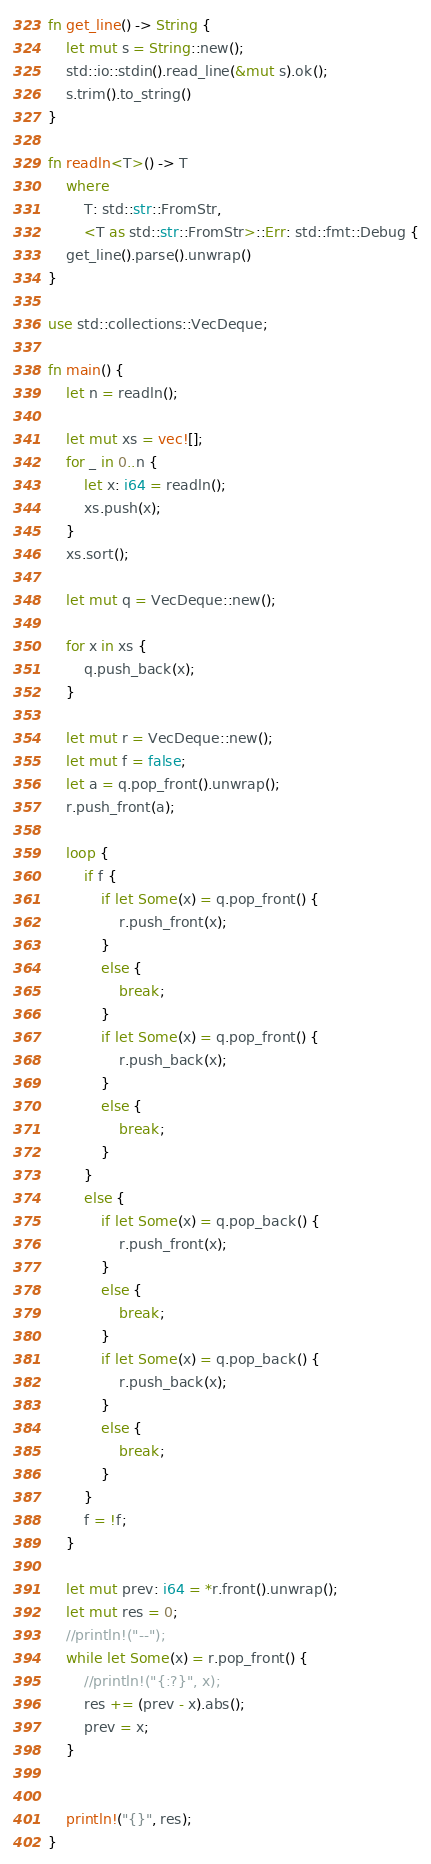<code> <loc_0><loc_0><loc_500><loc_500><_Rust_>fn get_line() -> String {
    let mut s = String::new();
    std::io::stdin().read_line(&mut s).ok();
    s.trim().to_string()
}

fn readln<T>() -> T
    where
        T: std::str::FromStr,
        <T as std::str::FromStr>::Err: std::fmt::Debug {
    get_line().parse().unwrap()
}

use std::collections::VecDeque;

fn main() {
    let n = readln();

    let mut xs = vec![];
    for _ in 0..n {
        let x: i64 = readln();
        xs.push(x);
    }
    xs.sort();

    let mut q = VecDeque::new();

    for x in xs {
        q.push_back(x);
    }

    let mut r = VecDeque::new();
    let mut f = false;
    let a = q.pop_front().unwrap();
    r.push_front(a);

    loop {
        if f {
            if let Some(x) = q.pop_front() {
                r.push_front(x);
            }
            else {
                break;
            }
            if let Some(x) = q.pop_front() {
                r.push_back(x);
            }
            else {
                break;
            }
        }
        else {
            if let Some(x) = q.pop_back() {
                r.push_front(x);
            }
            else {
                break;
            }
            if let Some(x) = q.pop_back() {
                r.push_back(x);
            }
            else {
                break;
            }
        }
        f = !f;
    }

    let mut prev: i64 = *r.front().unwrap();
    let mut res = 0;
    //println!("--");
    while let Some(x) = r.pop_front() {
        //println!("{:?}", x);
        res += (prev - x).abs();
        prev = x;
    }


    println!("{}", res);
}</code> 